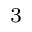<formula> <loc_0><loc_0><loc_500><loc_500>^ { 3 }</formula> 